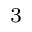<formula> <loc_0><loc_0><loc_500><loc_500>^ { 3 }</formula> 